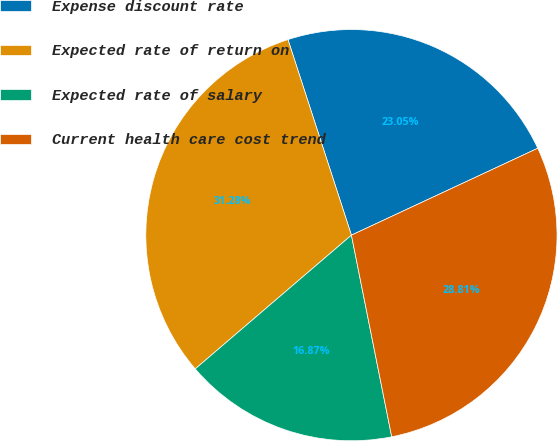Convert chart to OTSL. <chart><loc_0><loc_0><loc_500><loc_500><pie_chart><fcel>Expense discount rate<fcel>Expected rate of return on<fcel>Expected rate of salary<fcel>Current health care cost trend<nl><fcel>23.05%<fcel>31.28%<fcel>16.87%<fcel>28.81%<nl></chart> 